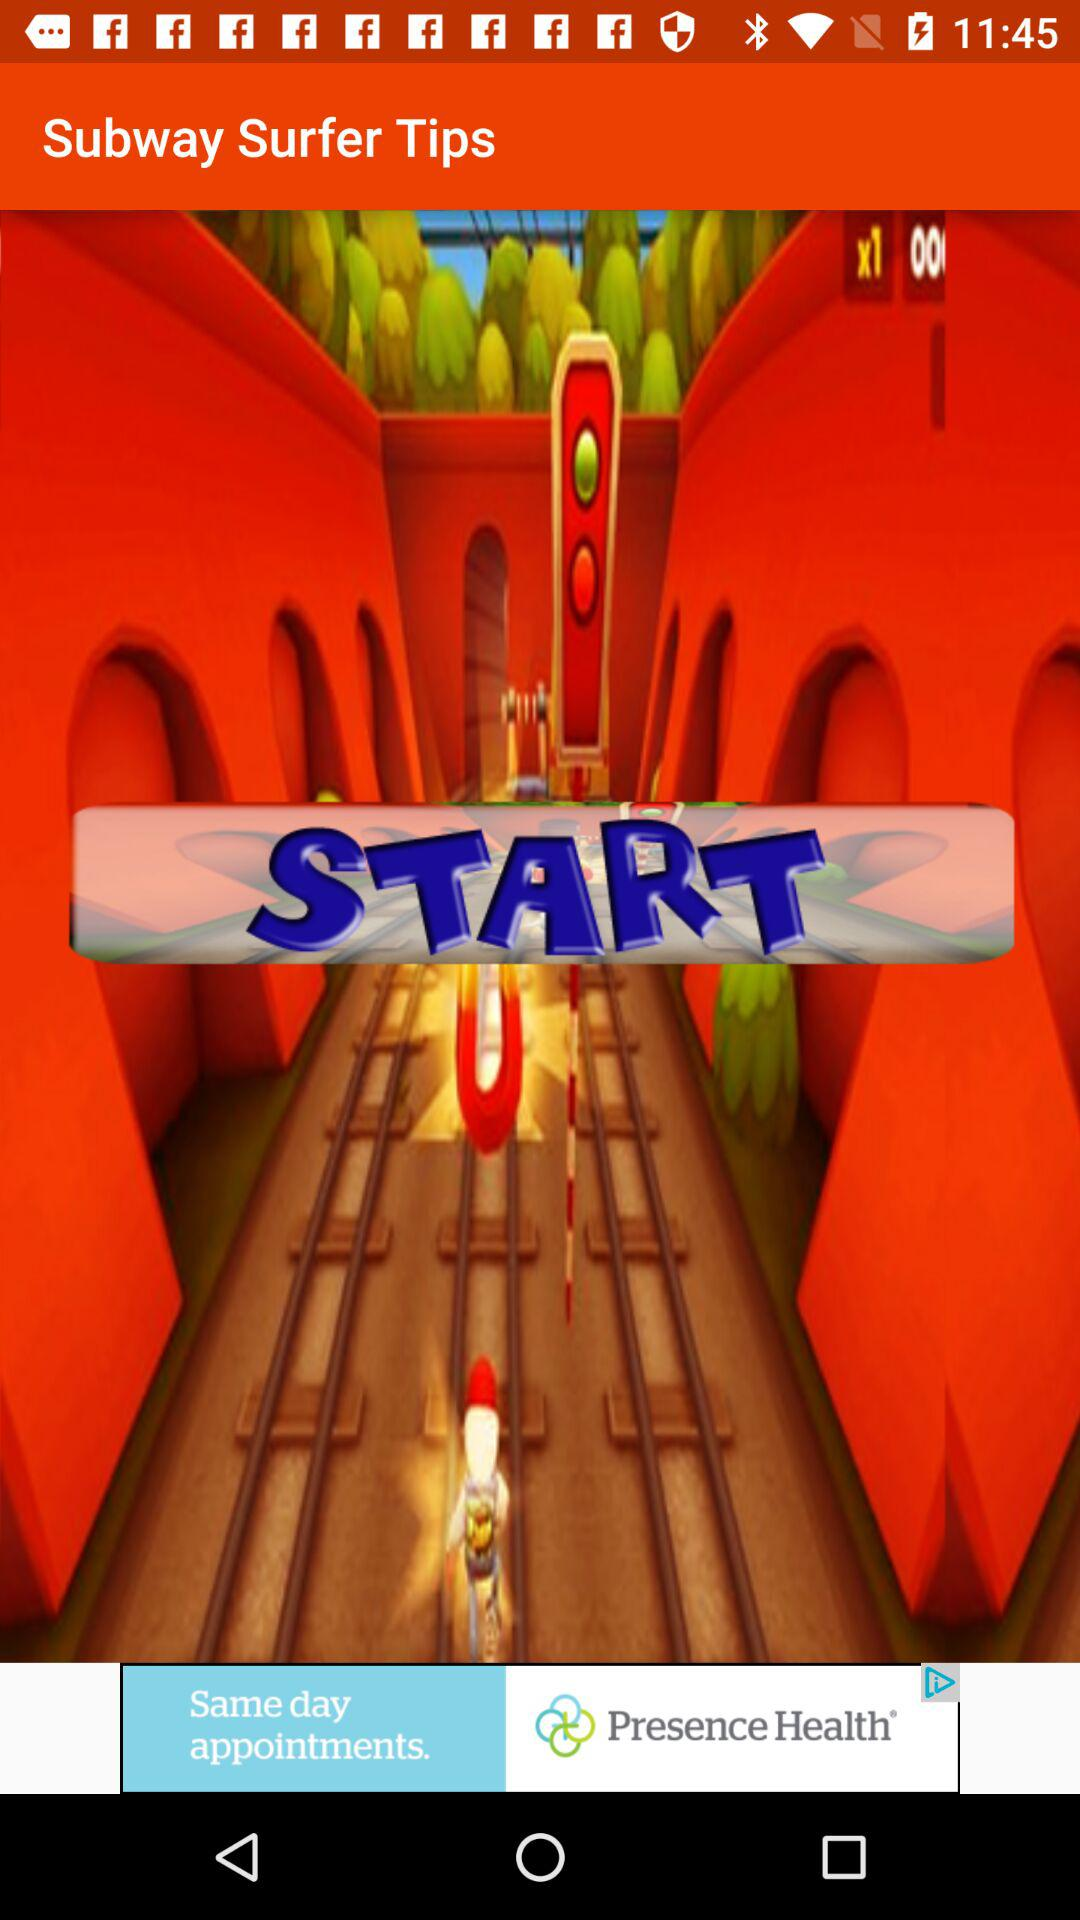What is the name of the application? The name of the application is "Subway Surfer Tips". 